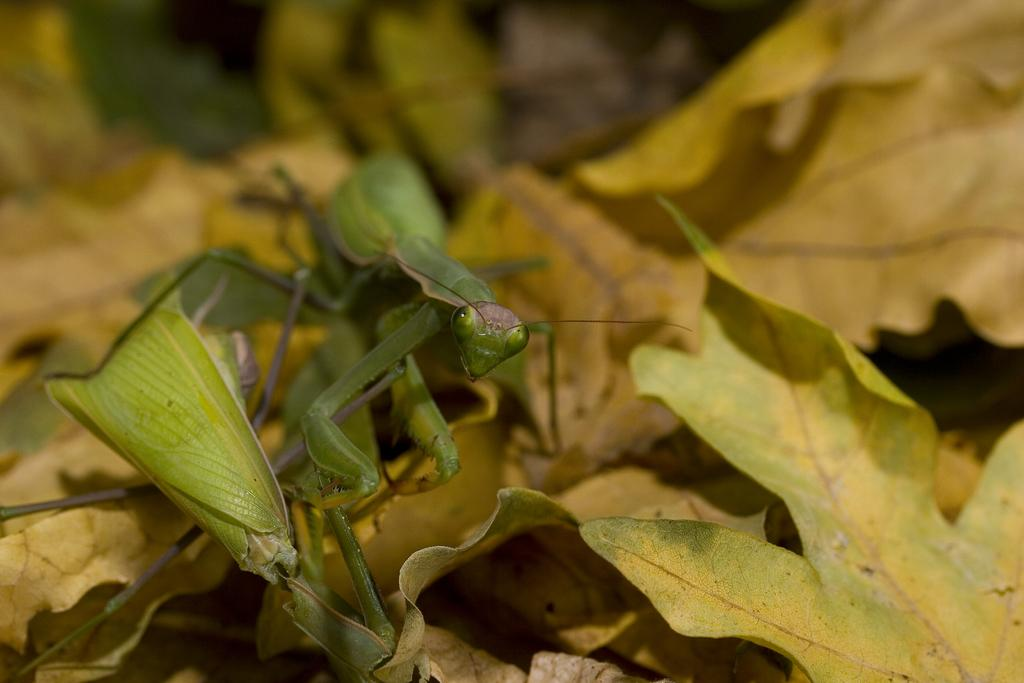What is the main subject of the image? The main subject of the image is a grasshopper. Where is the grasshopper located in the image? The grasshopper is on leaves in the image. Can you describe the position of the grasshopper in the image? The grasshopper is located in the center of the image. What type of protest is happening in the image? There is no protest present in the image; it features a grasshopper on leaves. Can you tell me how many ships are docked in the harbor in the image? There is no harbor or ships present in the image; it features a grasshopper on leaves. 